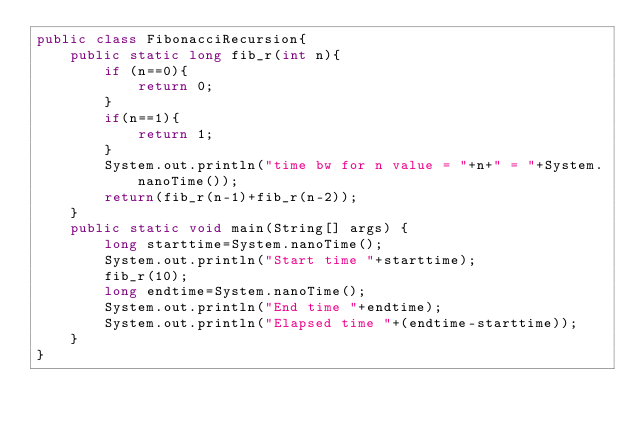<code> <loc_0><loc_0><loc_500><loc_500><_Java_>public class FibonacciRecursion{
    public static long fib_r(int n){
        if (n==0){
            return 0;
        }
        if(n==1){
            return 1;
        }
        System.out.println("time bw for n value = "+n+" = "+System.nanoTime());
        return(fib_r(n-1)+fib_r(n-2));
    }
    public static void main(String[] args) {
        long starttime=System.nanoTime();
        System.out.println("Start time "+starttime);
        fib_r(10);
        long endtime=System.nanoTime();
        System.out.println("End time "+endtime);
        System.out.println("Elapsed time "+(endtime-starttime));
    }
}</code> 